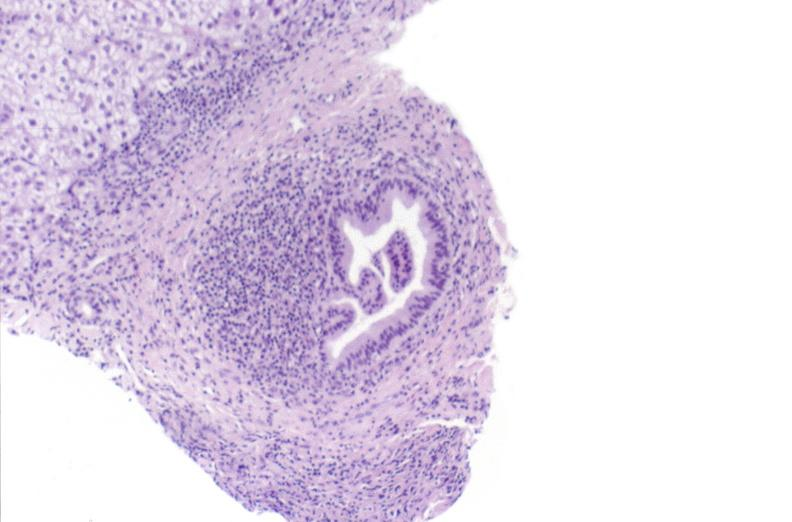what is present?
Answer the question using a single word or phrase. Hepatobiliary 